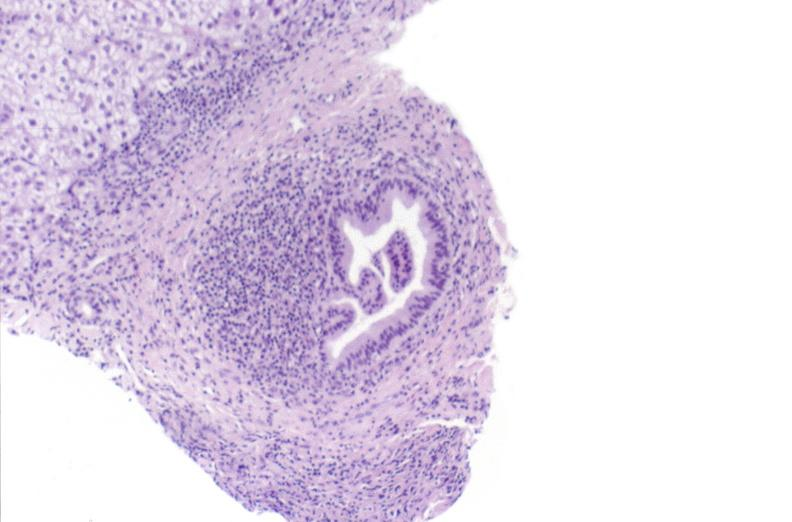what is present?
Answer the question using a single word or phrase. Hepatobiliary 